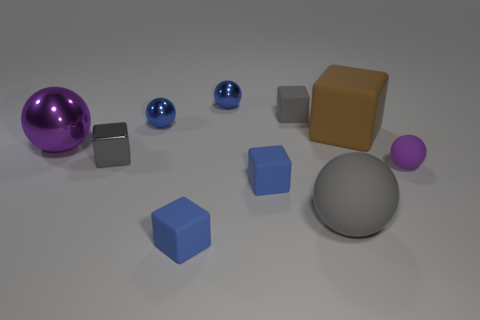The purple matte object that is to the right of the tiny rubber cube behind the large block is what shape?
Your answer should be very brief. Sphere. What number of other objects are the same shape as the large purple metal object?
Your response must be concise. 4. Are there any gray metal blocks right of the large brown cube?
Your response must be concise. No. The large shiny object has what color?
Make the answer very short. Purple. Does the small rubber ball have the same color as the block behind the brown matte thing?
Make the answer very short. No. Are there any blue objects of the same size as the brown cube?
Give a very brief answer. No. There is a sphere that is the same color as the big shiny thing; what is its size?
Give a very brief answer. Small. There is a gray block that is in front of the purple metallic sphere; what is its material?
Ensure brevity in your answer.  Metal. Are there the same number of small blue balls that are in front of the gray metallic block and gray things that are on the right side of the big gray matte object?
Give a very brief answer. Yes. There is a purple rubber object to the right of the brown matte block; is its size the same as the sphere that is to the left of the gray metallic block?
Provide a succinct answer. No. 